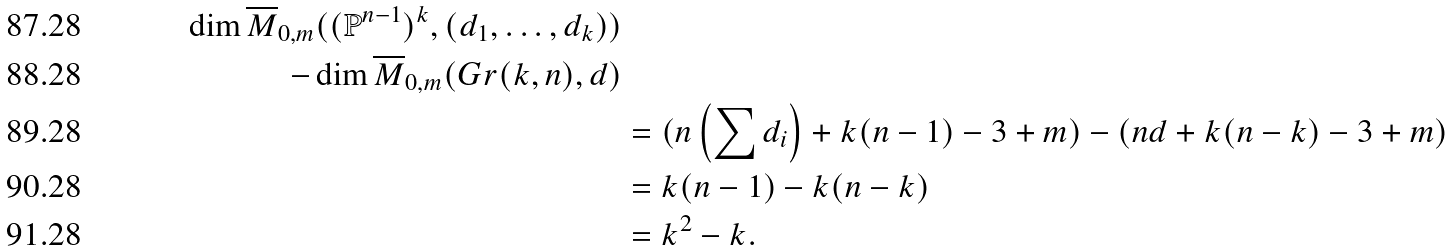Convert formula to latex. <formula><loc_0><loc_0><loc_500><loc_500>\dim \overline { M } _ { 0 , m } ( ( \mathbb { P } ^ { n - 1 } ) ^ { k } , ( d _ { 1 } , \dots , d _ { k } ) ) \\ - \dim \overline { M } _ { 0 , m } ( G r ( k , n ) , d ) \\ & = ( n \left ( \sum d _ { i } \right ) + k ( n - 1 ) - 3 + m ) - ( n d + k ( n - k ) - 3 + m ) \\ & = k ( n - 1 ) - k ( n - k ) \\ & = k ^ { 2 } - k .</formula> 